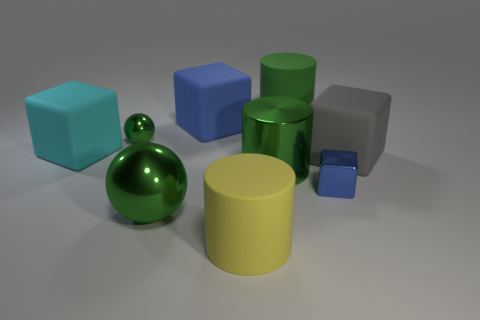Subtract all large cubes. How many cubes are left? 1 Subtract all blue cubes. How many cubes are left? 2 Add 1 brown shiny cylinders. How many objects exist? 10 Subtract 3 cubes. How many cubes are left? 1 Subtract all blocks. How many objects are left? 5 Subtract all red spheres. How many green cylinders are left? 2 Subtract all gray things. Subtract all brown things. How many objects are left? 8 Add 8 large cyan rubber cubes. How many large cyan rubber cubes are left? 9 Add 2 gray rubber cubes. How many gray rubber cubes exist? 3 Subtract 1 green cylinders. How many objects are left? 8 